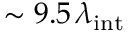<formula> <loc_0><loc_0><loc_500><loc_500>\sim 9 . 5 \, \lambda _ { i n t }</formula> 